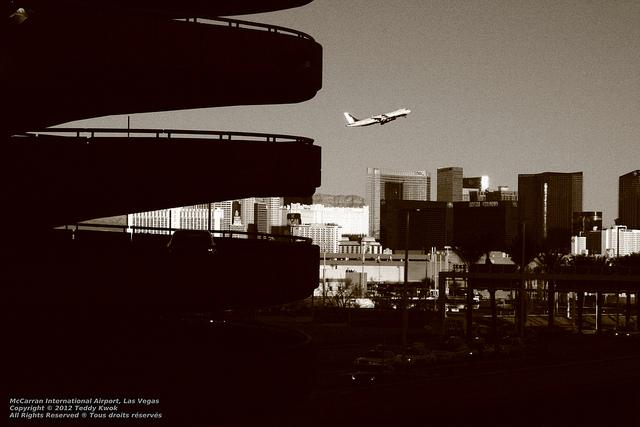What is taking off? Please explain your reasoning. airplane. An airplane is jetting off into the air. 